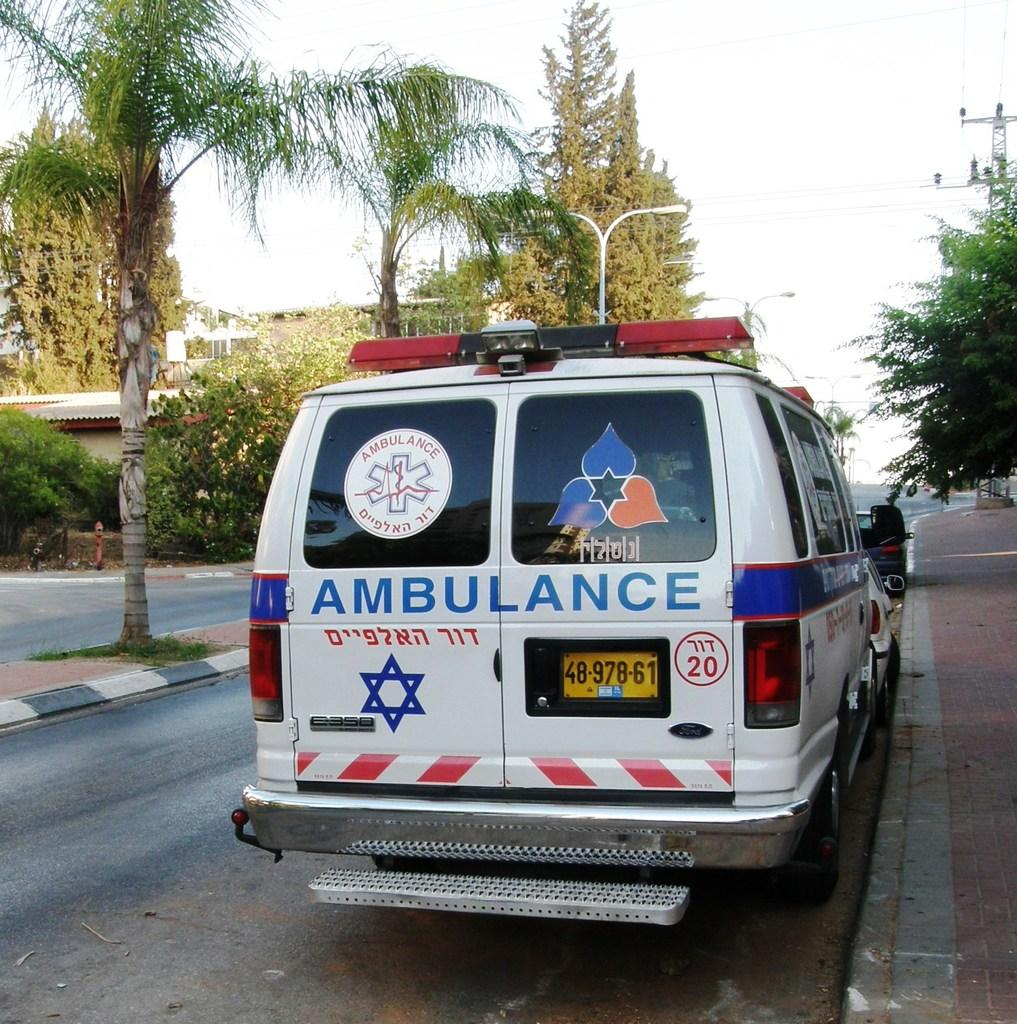Provide a one-sentence caption for the provided image. An ambulance with a Jewish star on the back is number 20. 